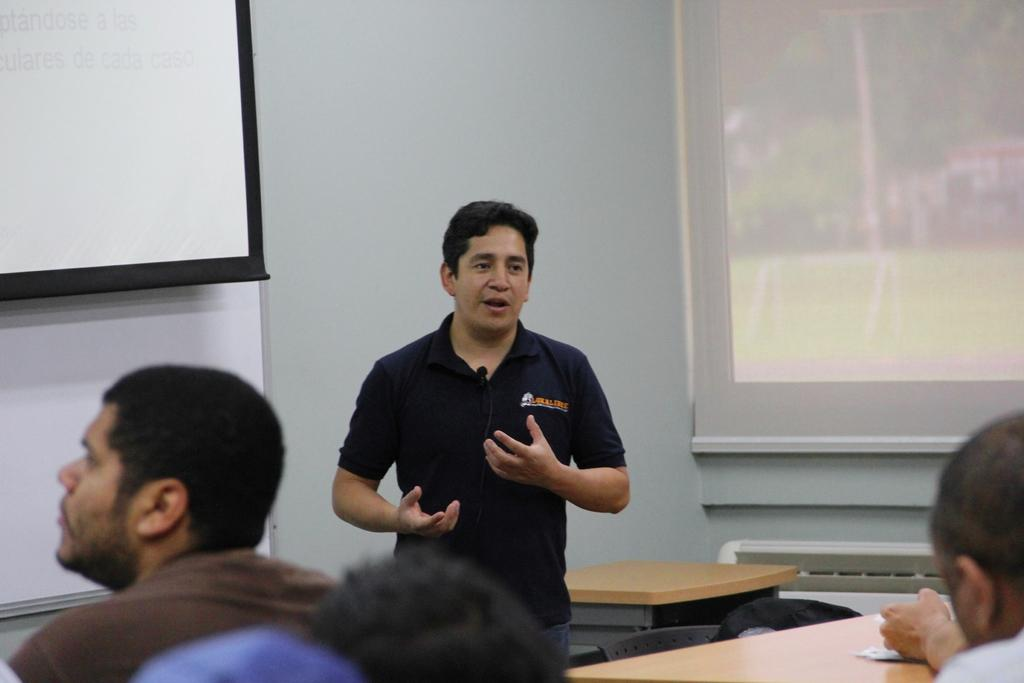What is the man in the image doing? The man is standing and talking in the image. Who is the man addressing in the image? There are people sitting in front of the man, so he is likely addressing them. What is the arrangement of the tables in the image? Tables are arranged in front of the man. What is visible behind the man in the image? There is a screen behind the man. What can be seen in the background of the image? There is a window in the background of the image. What type of attraction is the man using to measure the distance between the tables? There is no attraction or measuring device present in the image; the man is simply standing and talking. 